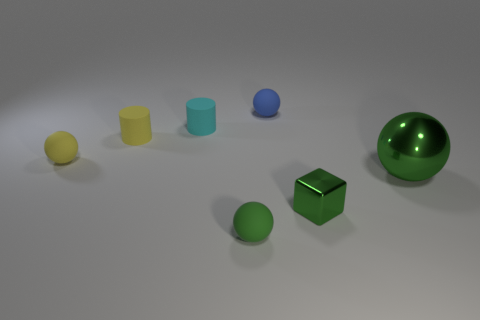Add 3 small cyan matte objects. How many objects exist? 10 Subtract all cylinders. How many objects are left? 5 Subtract 0 brown cylinders. How many objects are left? 7 Subtract all big gray matte cylinders. Subtract all big metal balls. How many objects are left? 6 Add 5 small matte spheres. How many small matte spheres are left? 8 Add 3 yellow matte cylinders. How many yellow matte cylinders exist? 4 